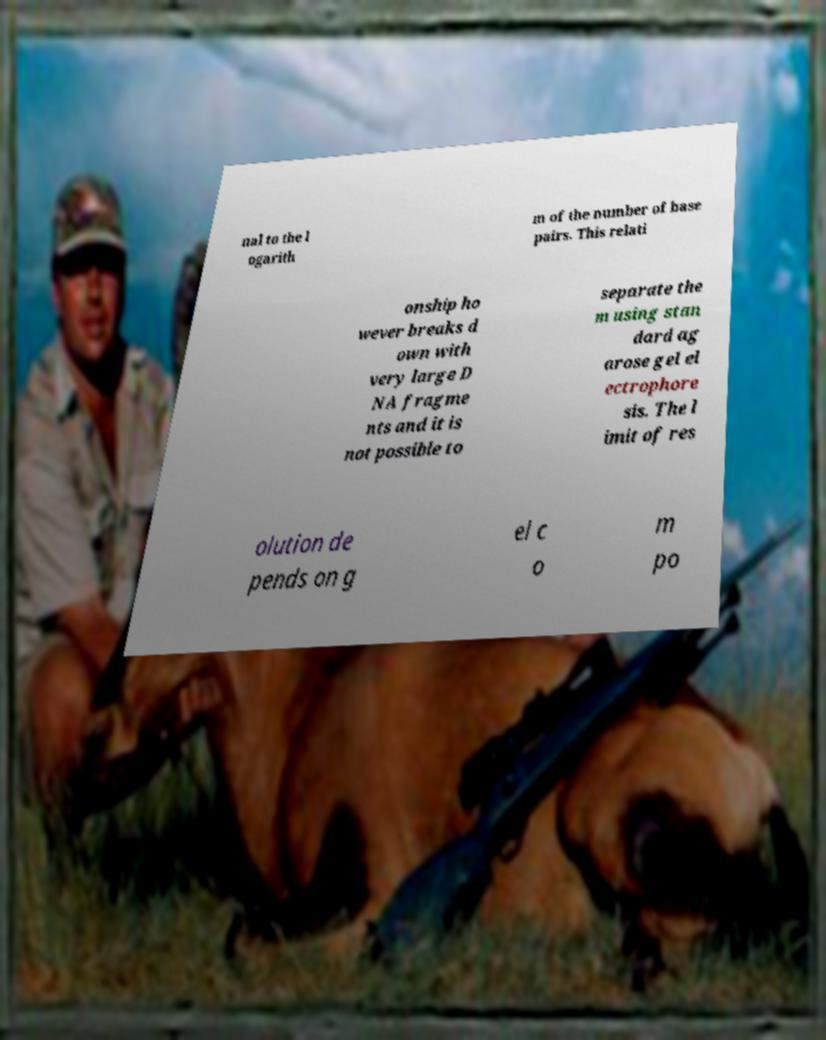Please identify and transcribe the text found in this image. nal to the l ogarith m of the number of base pairs. This relati onship ho wever breaks d own with very large D NA fragme nts and it is not possible to separate the m using stan dard ag arose gel el ectrophore sis. The l imit of res olution de pends on g el c o m po 